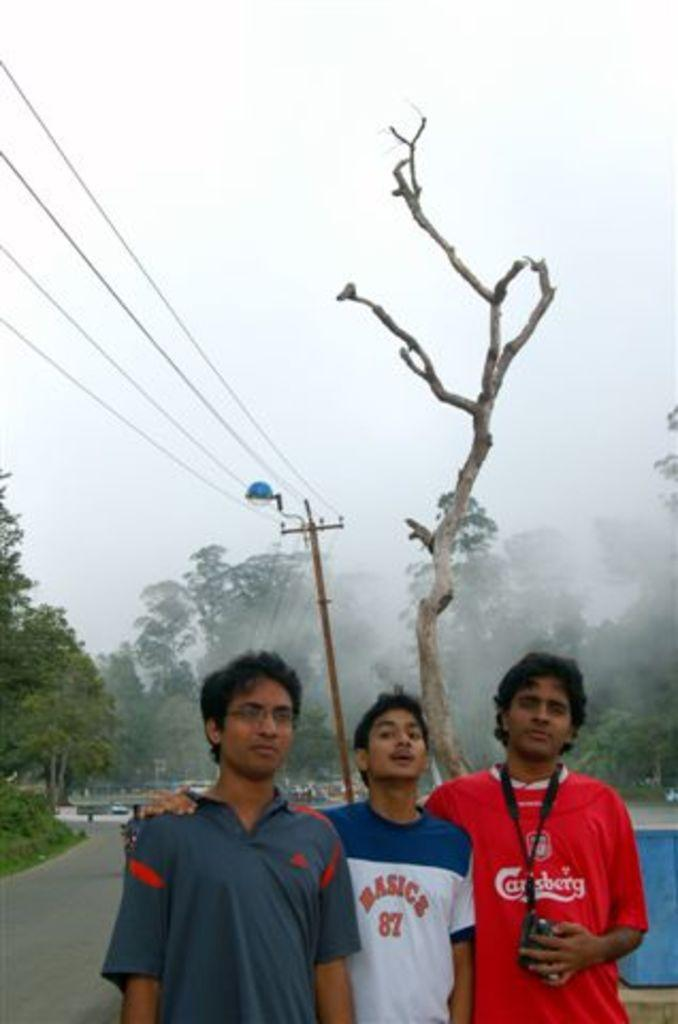<image>
Render a clear and concise summary of the photo. Boy wearing a shirt that says Basics in the middle of two other boys. 